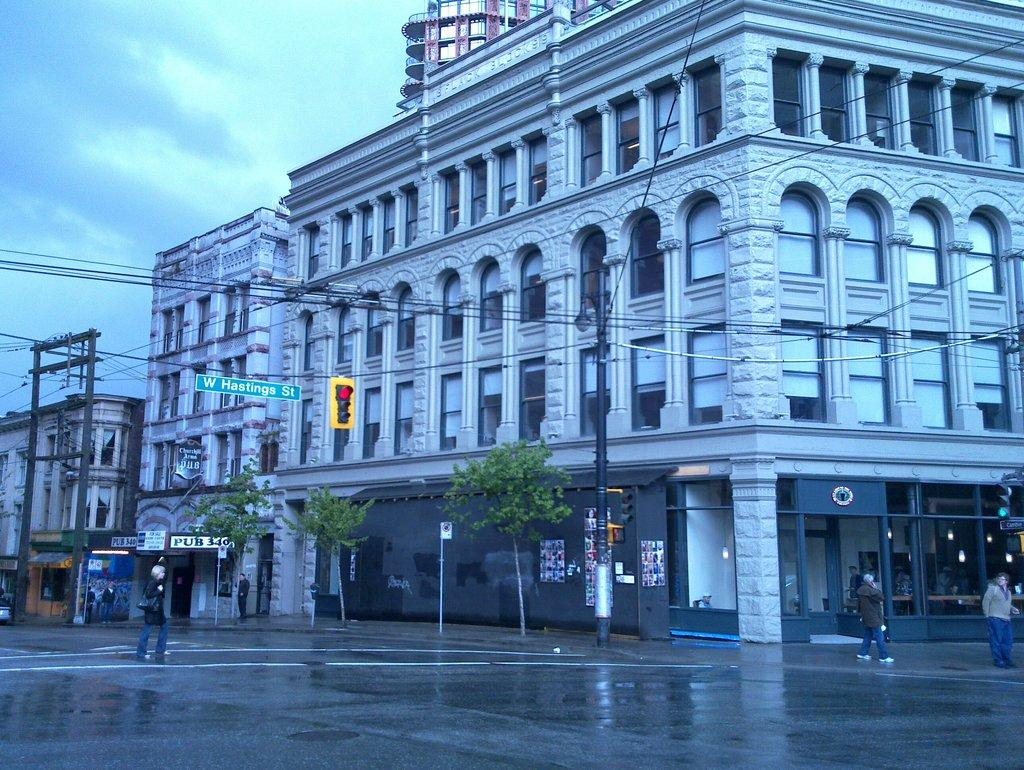What can be seen in the background of the image? In the background of the image, there are trees, buildings, street lights, and a traffic signal. What type of environment is depicted in the image? The image shows an urban environment with trees and buildings. What is the weather like in the image? The sky is cloudy in the image, indicating a potentially overcast or rainy day. What are the people in the image doing? The people in the image are walking on a path. Can you tell me how many passengers are waiting for the riverboat in the image? There is no river or riverboat present in the image; it features an urban environment with trees, buildings, street lights, and a traffic signal. What type of pull-up exercise can be seen being performed by the people in the image? There is no exercise or physical activity being performed by the people in the image; they are simply walking on a path. 